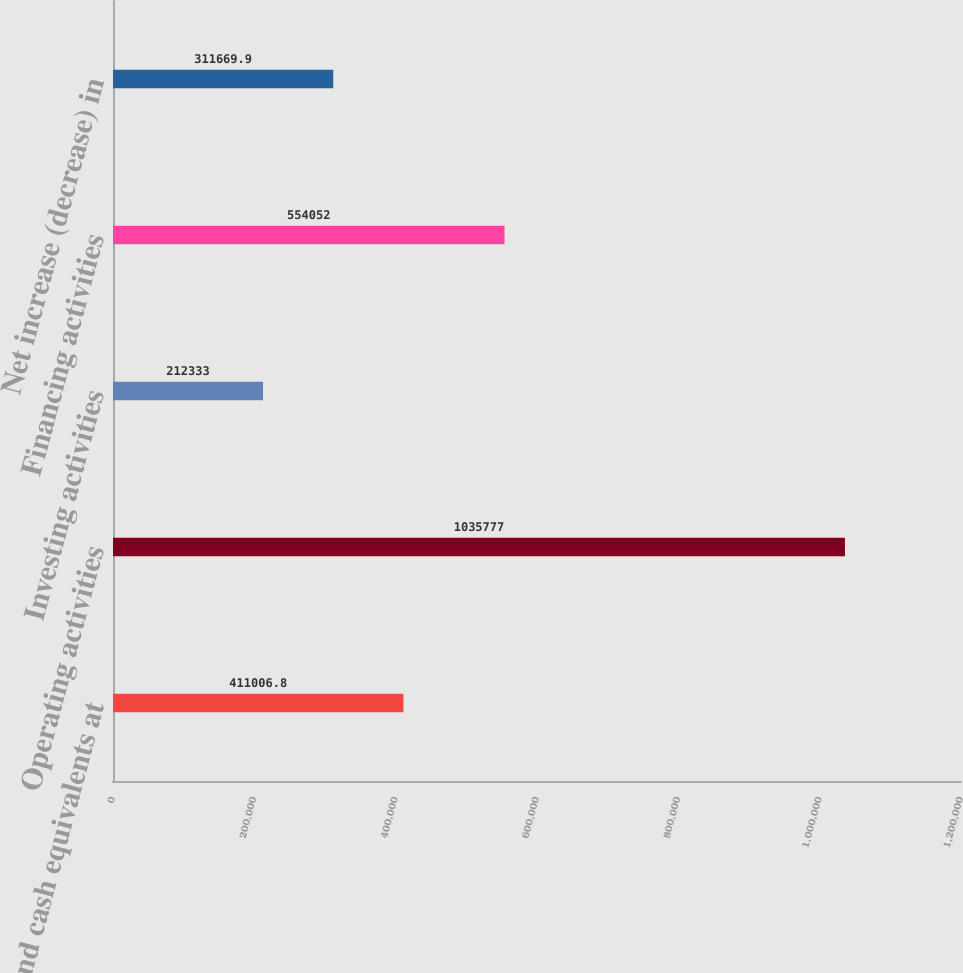Convert chart to OTSL. <chart><loc_0><loc_0><loc_500><loc_500><bar_chart><fcel>Cash and cash equivalents at<fcel>Operating activities<fcel>Investing activities<fcel>Financing activities<fcel>Net increase (decrease) in<nl><fcel>411007<fcel>1.03578e+06<fcel>212333<fcel>554052<fcel>311670<nl></chart> 